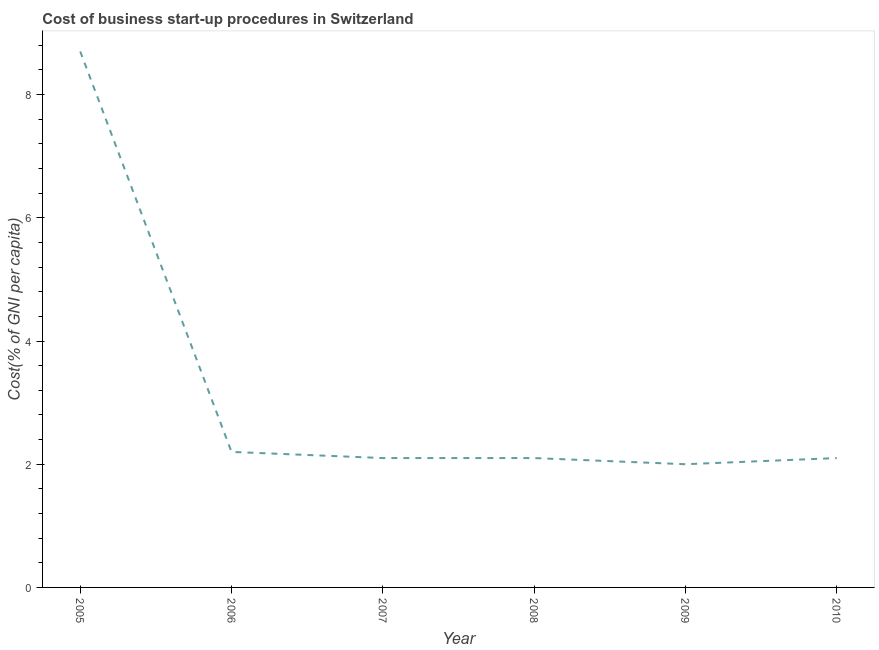What is the sum of the cost of business startup procedures?
Your answer should be very brief. 19.2. What is the difference between the cost of business startup procedures in 2008 and 2009?
Offer a terse response. 0.1. What is the average cost of business startup procedures per year?
Give a very brief answer. 3.2. In how many years, is the cost of business startup procedures greater than 6.8 %?
Provide a succinct answer. 1. Do a majority of the years between 2006 and 2007 (inclusive) have cost of business startup procedures greater than 4.4 %?
Offer a very short reply. No. What is the ratio of the cost of business startup procedures in 2009 to that in 2010?
Make the answer very short. 0.95. Is the cost of business startup procedures in 2005 less than that in 2007?
Ensure brevity in your answer.  No. Is the difference between the cost of business startup procedures in 2008 and 2009 greater than the difference between any two years?
Your answer should be compact. No. What is the difference between the highest and the second highest cost of business startup procedures?
Make the answer very short. 6.5. Is the sum of the cost of business startup procedures in 2007 and 2008 greater than the maximum cost of business startup procedures across all years?
Offer a terse response. No. What is the difference between the highest and the lowest cost of business startup procedures?
Give a very brief answer. 6.7. In how many years, is the cost of business startup procedures greater than the average cost of business startup procedures taken over all years?
Keep it short and to the point. 1. Does the cost of business startup procedures monotonically increase over the years?
Offer a terse response. No. Are the values on the major ticks of Y-axis written in scientific E-notation?
Ensure brevity in your answer.  No. Does the graph contain any zero values?
Keep it short and to the point. No. Does the graph contain grids?
Ensure brevity in your answer.  No. What is the title of the graph?
Give a very brief answer. Cost of business start-up procedures in Switzerland. What is the label or title of the X-axis?
Your response must be concise. Year. What is the label or title of the Y-axis?
Your response must be concise. Cost(% of GNI per capita). What is the Cost(% of GNI per capita) in 2005?
Offer a terse response. 8.7. What is the Cost(% of GNI per capita) of 2007?
Give a very brief answer. 2.1. What is the Cost(% of GNI per capita) of 2010?
Ensure brevity in your answer.  2.1. What is the difference between the Cost(% of GNI per capita) in 2005 and 2006?
Your response must be concise. 6.5. What is the difference between the Cost(% of GNI per capita) in 2005 and 2009?
Offer a very short reply. 6.7. What is the difference between the Cost(% of GNI per capita) in 2005 and 2010?
Offer a terse response. 6.6. What is the difference between the Cost(% of GNI per capita) in 2006 and 2007?
Offer a terse response. 0.1. What is the difference between the Cost(% of GNI per capita) in 2006 and 2010?
Make the answer very short. 0.1. What is the difference between the Cost(% of GNI per capita) in 2007 and 2009?
Offer a terse response. 0.1. What is the difference between the Cost(% of GNI per capita) in 2008 and 2009?
Ensure brevity in your answer.  0.1. What is the difference between the Cost(% of GNI per capita) in 2008 and 2010?
Provide a short and direct response. 0. What is the difference between the Cost(% of GNI per capita) in 2009 and 2010?
Provide a succinct answer. -0.1. What is the ratio of the Cost(% of GNI per capita) in 2005 to that in 2006?
Provide a short and direct response. 3.96. What is the ratio of the Cost(% of GNI per capita) in 2005 to that in 2007?
Provide a short and direct response. 4.14. What is the ratio of the Cost(% of GNI per capita) in 2005 to that in 2008?
Give a very brief answer. 4.14. What is the ratio of the Cost(% of GNI per capita) in 2005 to that in 2009?
Provide a short and direct response. 4.35. What is the ratio of the Cost(% of GNI per capita) in 2005 to that in 2010?
Keep it short and to the point. 4.14. What is the ratio of the Cost(% of GNI per capita) in 2006 to that in 2007?
Give a very brief answer. 1.05. What is the ratio of the Cost(% of GNI per capita) in 2006 to that in 2008?
Provide a succinct answer. 1.05. What is the ratio of the Cost(% of GNI per capita) in 2006 to that in 2010?
Keep it short and to the point. 1.05. What is the ratio of the Cost(% of GNI per capita) in 2007 to that in 2009?
Make the answer very short. 1.05. What is the ratio of the Cost(% of GNI per capita) in 2008 to that in 2010?
Offer a very short reply. 1. 